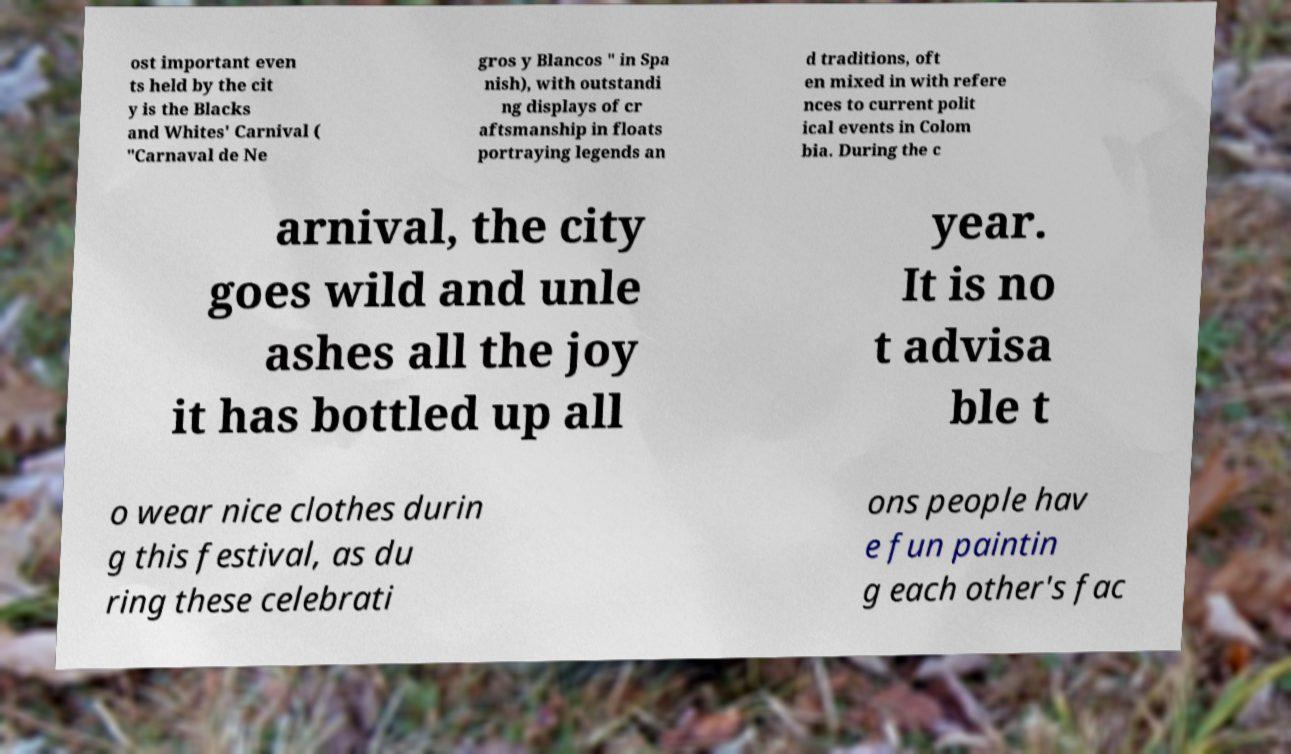Could you extract and type out the text from this image? ost important even ts held by the cit y is the Blacks and Whites' Carnival ( "Carnaval de Ne gros y Blancos " in Spa nish), with outstandi ng displays of cr aftsmanship in floats portraying legends an d traditions, oft en mixed in with refere nces to current polit ical events in Colom bia. During the c arnival, the city goes wild and unle ashes all the joy it has bottled up all year. It is no t advisa ble t o wear nice clothes durin g this festival, as du ring these celebrati ons people hav e fun paintin g each other's fac 